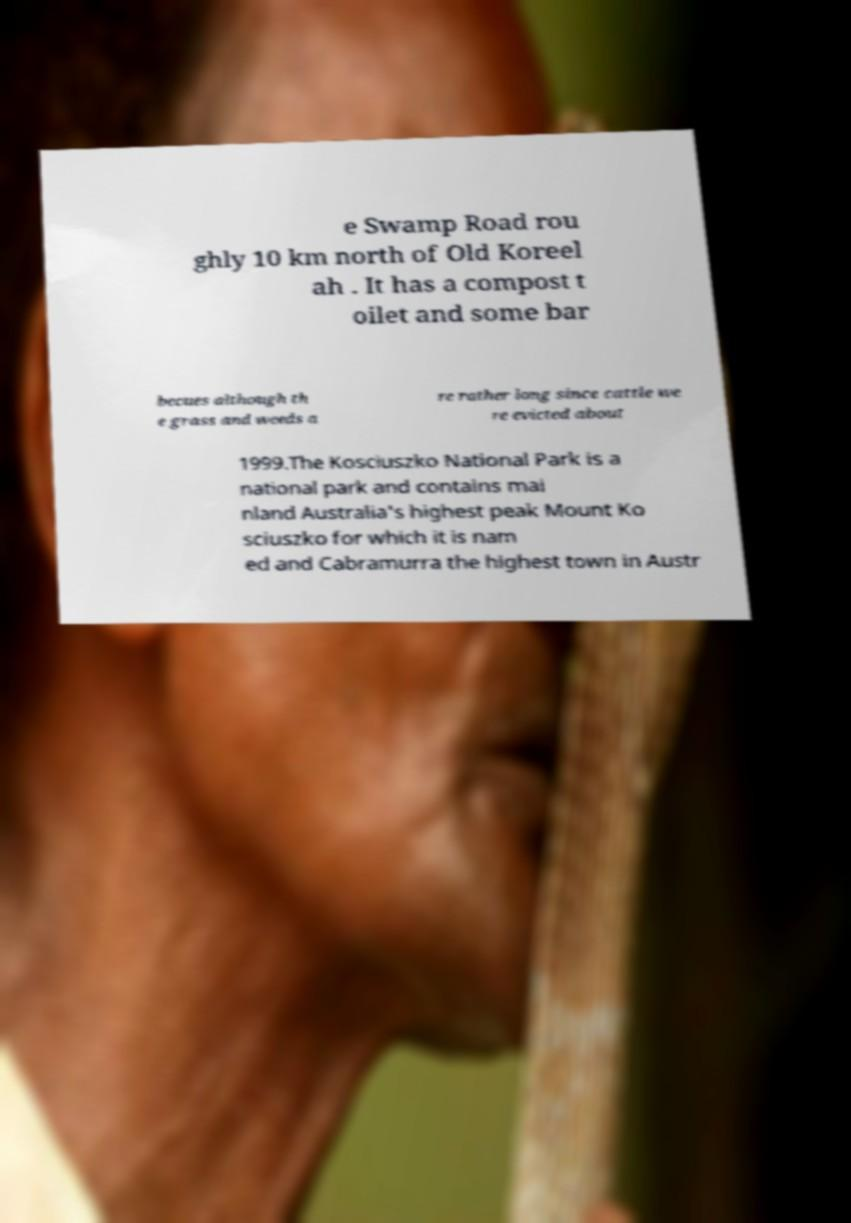Could you assist in decoding the text presented in this image and type it out clearly? e Swamp Road rou ghly 10 km north of Old Koreel ah . It has a compost t oilet and some bar becues although th e grass and weeds a re rather long since cattle we re evicted about 1999.The Kosciuszko National Park is a national park and contains mai nland Australia's highest peak Mount Ko sciuszko for which it is nam ed and Cabramurra the highest town in Austr 